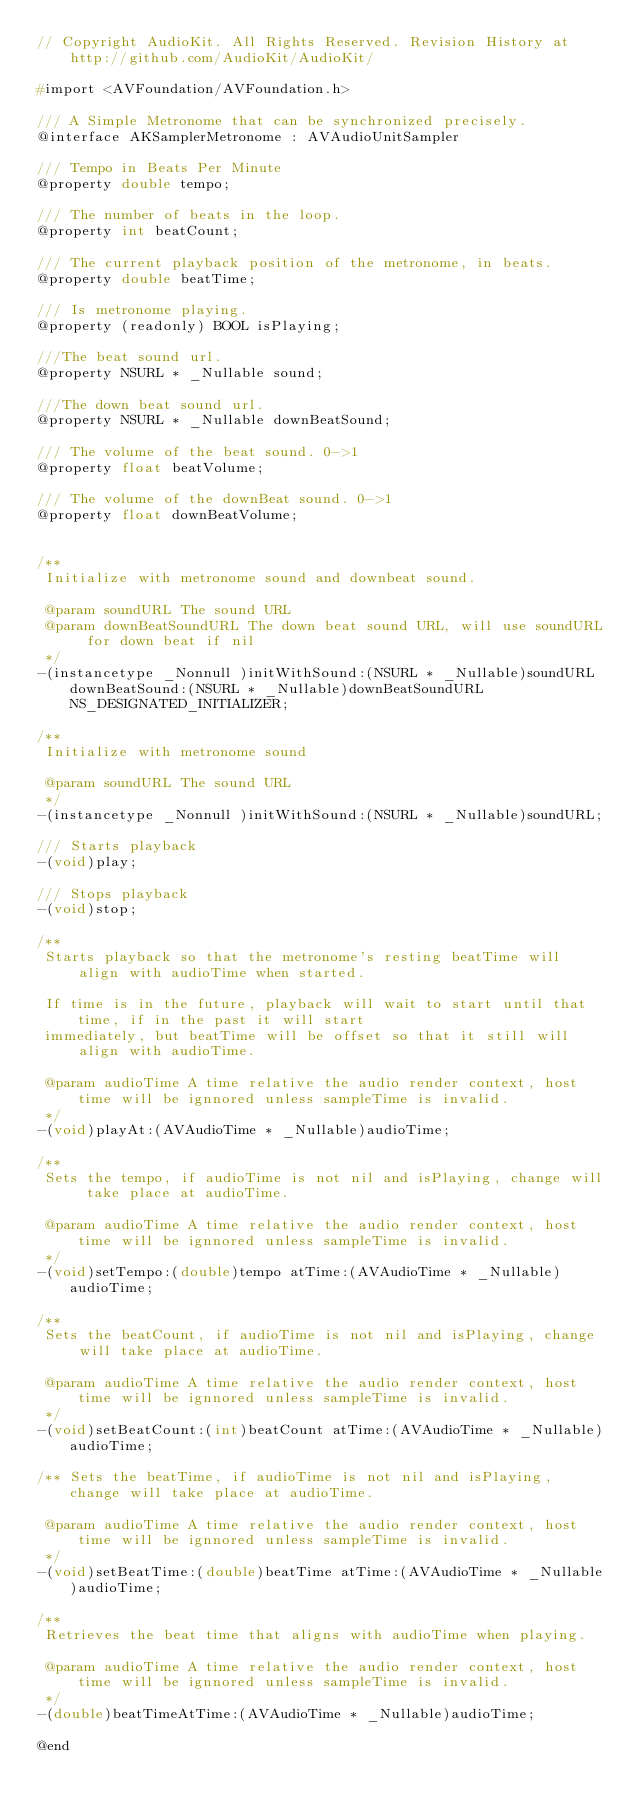Convert code to text. <code><loc_0><loc_0><loc_500><loc_500><_C_>// Copyright AudioKit. All Rights Reserved. Revision History at http://github.com/AudioKit/AudioKit/

#import <AVFoundation/AVFoundation.h>

/// A Simple Metronome that can be synchronized precisely.
@interface AKSamplerMetronome : AVAudioUnitSampler

/// Tempo in Beats Per Minute
@property double tempo;

/// The number of beats in the loop.
@property int beatCount;

/// The current playback position of the metronome, in beats.
@property double beatTime;

/// Is metronome playing.
@property (readonly) BOOL isPlaying;

///The beat sound url.
@property NSURL * _Nullable sound;

///The down beat sound url.
@property NSURL * _Nullable downBeatSound;

/// The volume of the beat sound. 0->1
@property float beatVolume;

/// The volume of the downBeat sound. 0->1
@property float downBeatVolume;


/**
 Initialize with metronome sound and downbeat sound.

 @param soundURL The sound URL
 @param downBeatSoundURL The down beat sound URL, will use soundURL for down beat if nil
 */
-(instancetype _Nonnull )initWithSound:(NSURL * _Nullable)soundURL downBeatSound:(NSURL * _Nullable)downBeatSoundURL NS_DESIGNATED_INITIALIZER;

/**
 Initialize with metronome sound

 @param soundURL The sound URL
 */
-(instancetype _Nonnull )initWithSound:(NSURL * _Nullable)soundURL;

/// Starts playback
-(void)play;

/// Stops playback
-(void)stop;

/**
 Starts playback so that the metronome's resting beatTime will align with audioTime when started.

 If time is in the future, playback will wait to start until that time, if in the past it will start
 immediately, but beatTime will be offset so that it still will align with audioTime.

 @param audioTime A time relative the audio render context, host time will be ignnored unless sampleTime is invalid.
 */
-(void)playAt:(AVAudioTime * _Nullable)audioTime;

/**
 Sets the tempo, if audioTime is not nil and isPlaying, change will take place at audioTime.

 @param audioTime A time relative the audio render context, host time will be ignnored unless sampleTime is invalid.
 */
-(void)setTempo:(double)tempo atTime:(AVAudioTime * _Nullable)audioTime;

/**
 Sets the beatCount, if audioTime is not nil and isPlaying, change will take place at audioTime.

 @param audioTime A time relative the audio render context, host time will be ignnored unless sampleTime is invalid.
 */
-(void)setBeatCount:(int)beatCount atTime:(AVAudioTime * _Nullable)audioTime;

/** Sets the beatTime, if audioTime is not nil and isPlaying, change will take place at audioTime.

 @param audioTime A time relative the audio render context, host time will be ignnored unless sampleTime is invalid.
 */
-(void)setBeatTime:(double)beatTime atTime:(AVAudioTime * _Nullable)audioTime;

/**
 Retrieves the beat time that aligns with audioTime when playing.

 @param audioTime A time relative the audio render context, host time will be ignnored unless sampleTime is invalid.
 */
-(double)beatTimeAtTime:(AVAudioTime * _Nullable)audioTime;

@end
</code> 